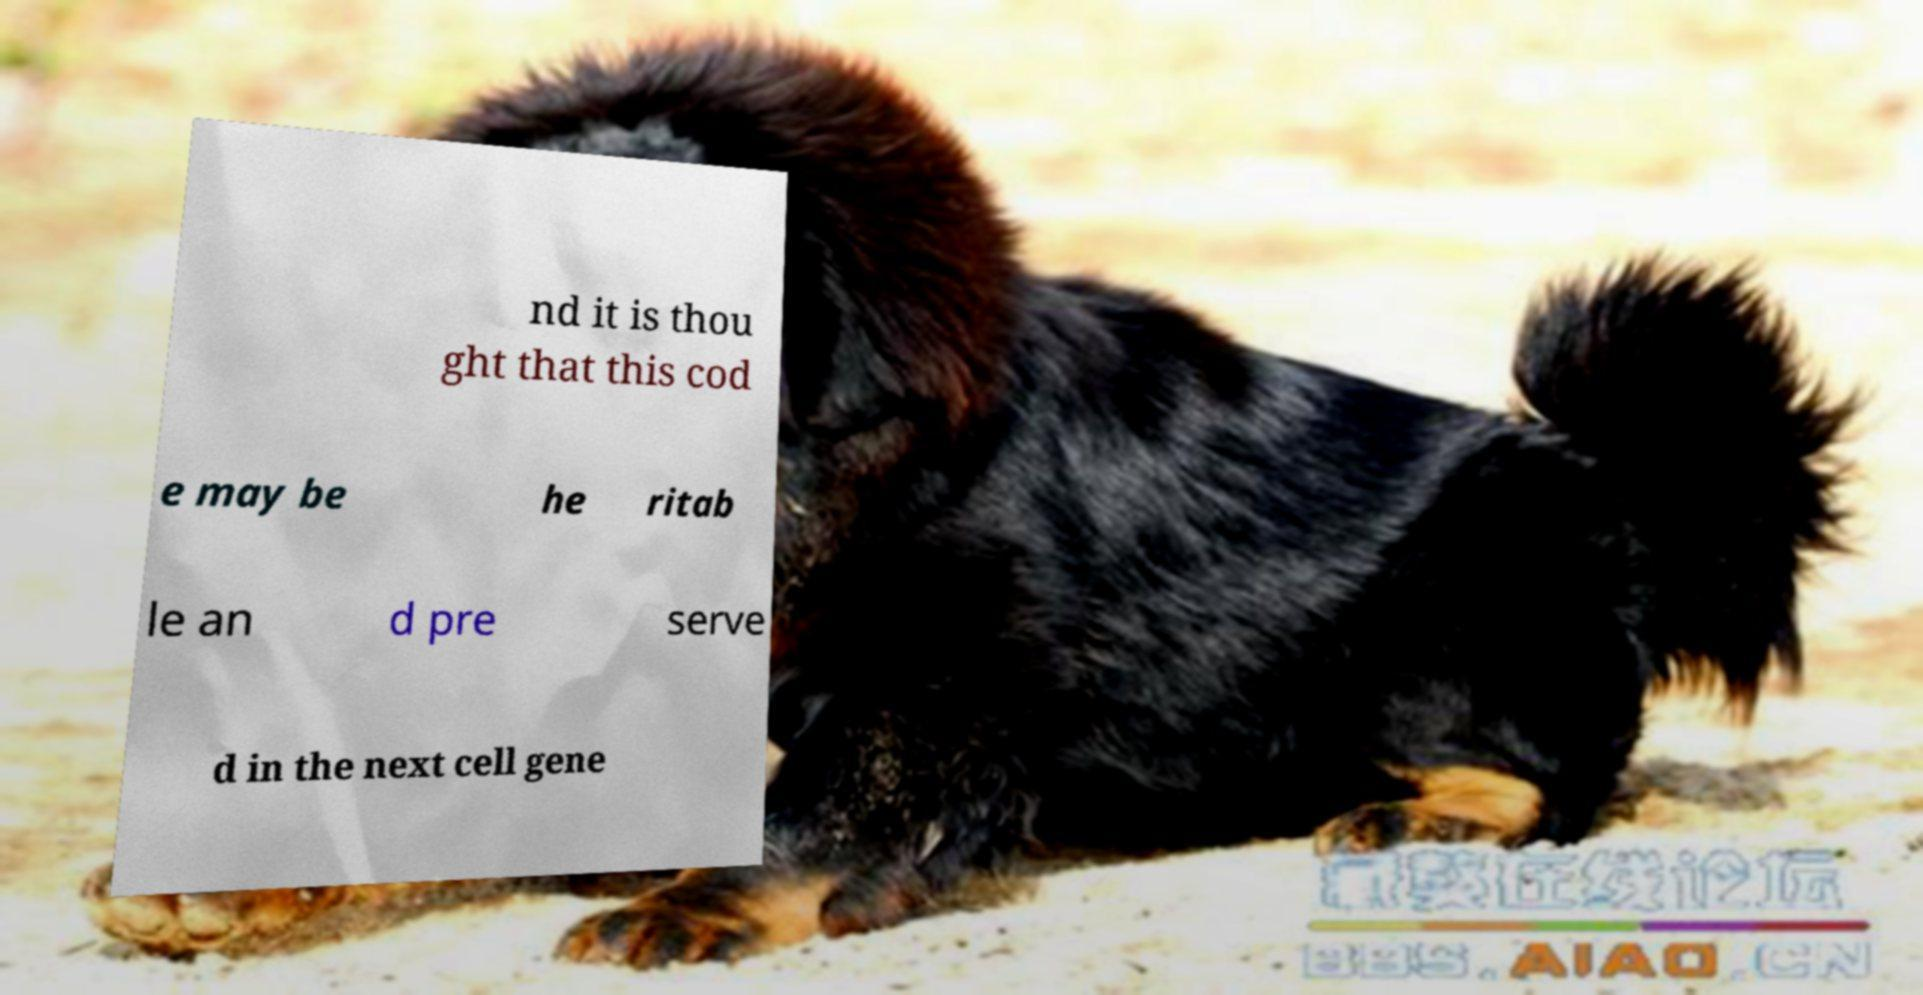Could you assist in decoding the text presented in this image and type it out clearly? nd it is thou ght that this cod e may be he ritab le an d pre serve d in the next cell gene 